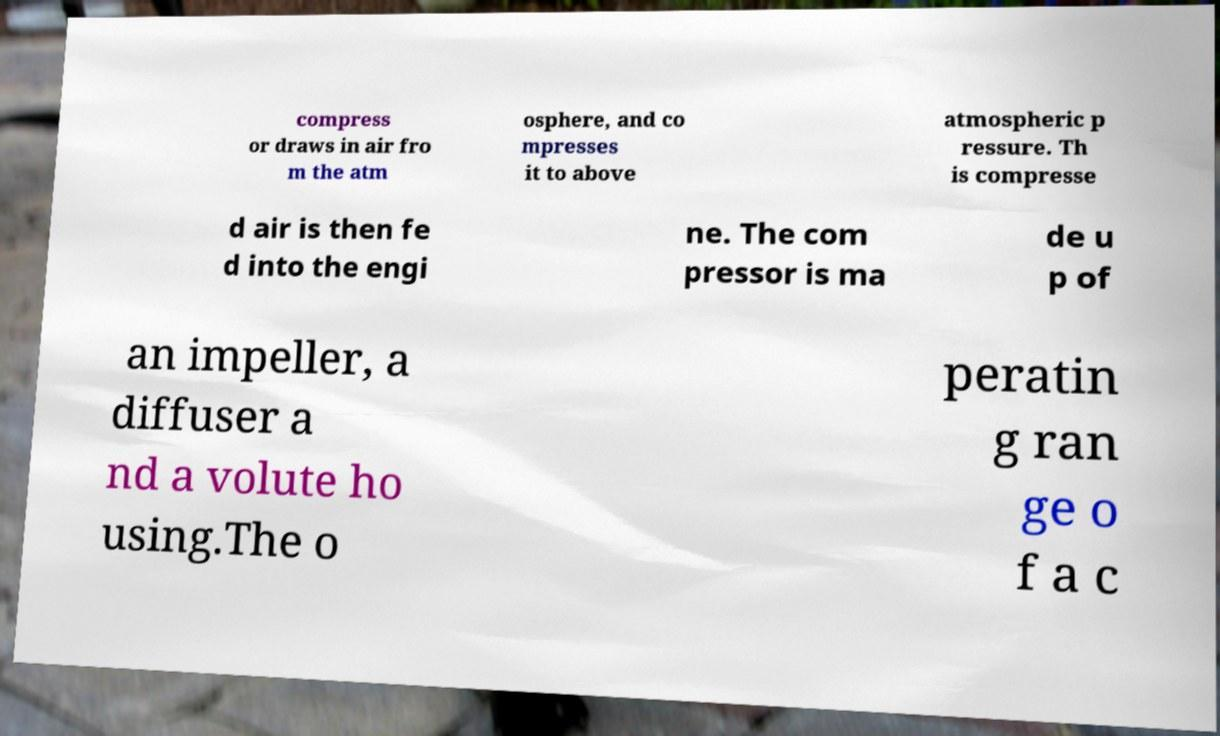Can you read and provide the text displayed in the image?This photo seems to have some interesting text. Can you extract and type it out for me? compress or draws in air fro m the atm osphere, and co mpresses it to above atmospheric p ressure. Th is compresse d air is then fe d into the engi ne. The com pressor is ma de u p of an impeller, a diffuser a nd a volute ho using.The o peratin g ran ge o f a c 